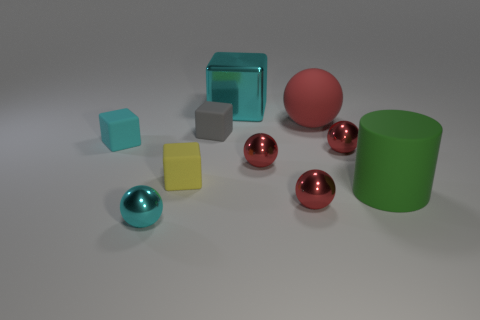What material is the small ball that is the same color as the big shiny block?
Give a very brief answer. Metal. Does the cyan matte thing have the same size as the cyan shiny ball?
Provide a succinct answer. Yes. There is a red metal thing right of the small red shiny sphere in front of the yellow rubber thing; how big is it?
Your answer should be compact. Small. The cyan ball is what size?
Offer a terse response. Small. What shape is the thing that is behind the small yellow object and right of the big sphere?
Keep it short and to the point. Sphere. The rubber thing that is the same shape as the small cyan metal thing is what color?
Keep it short and to the point. Red. There is a shiny object that is the same color as the big metal block; what is its shape?
Your answer should be compact. Sphere. What color is the large cylinder?
Your answer should be compact. Green. The cylinder that is the same size as the rubber sphere is what color?
Keep it short and to the point. Green. Are there any metallic balls of the same color as the matte sphere?
Offer a terse response. Yes. 